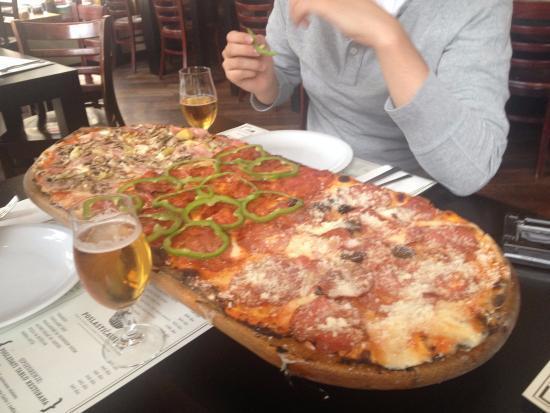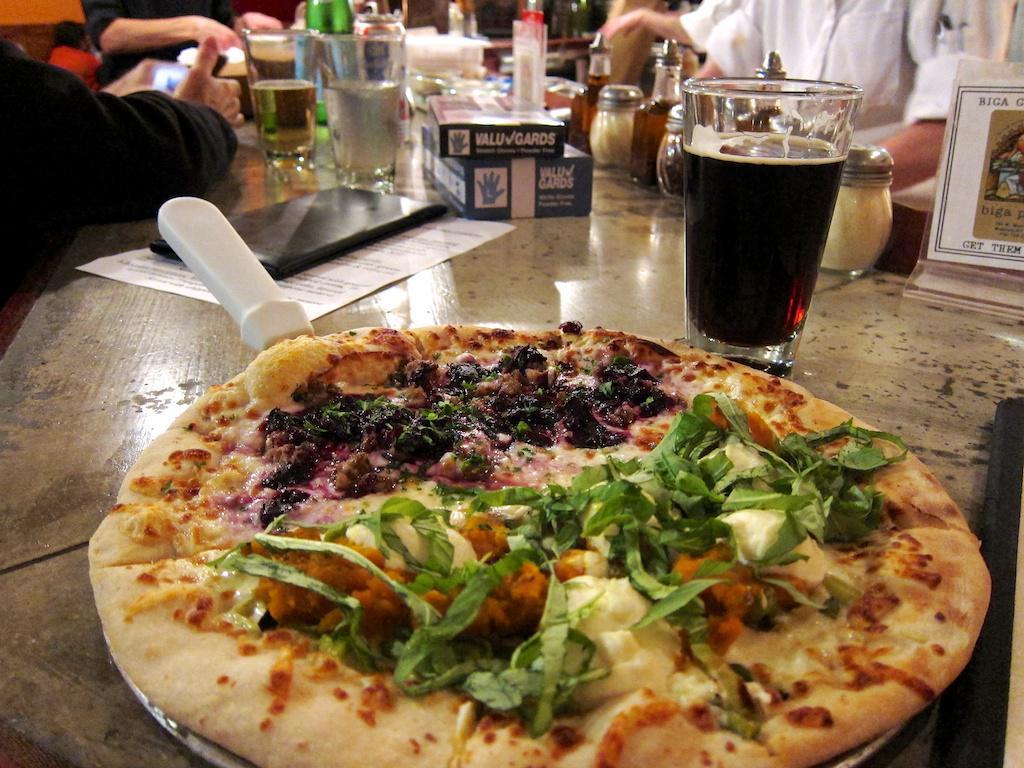The first image is the image on the left, the second image is the image on the right. Evaluate the accuracy of this statement regarding the images: "The left and right image contains the same number of circle shaped pizzas.". Is it true? Answer yes or no. No. 